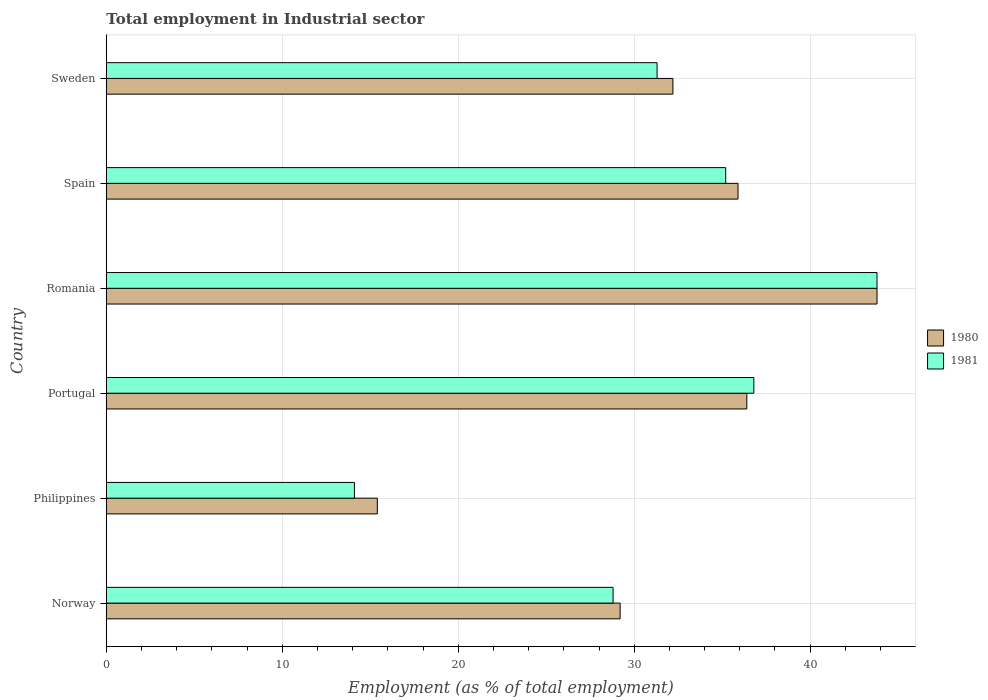How many groups of bars are there?
Offer a very short reply. 6. Are the number of bars per tick equal to the number of legend labels?
Make the answer very short. Yes. Are the number of bars on each tick of the Y-axis equal?
Your answer should be very brief. Yes. What is the label of the 2nd group of bars from the top?
Give a very brief answer. Spain. In how many cases, is the number of bars for a given country not equal to the number of legend labels?
Provide a succinct answer. 0. What is the employment in industrial sector in 1981 in Philippines?
Keep it short and to the point. 14.1. Across all countries, what is the maximum employment in industrial sector in 1980?
Your answer should be very brief. 43.8. Across all countries, what is the minimum employment in industrial sector in 1981?
Make the answer very short. 14.1. In which country was the employment in industrial sector in 1980 maximum?
Make the answer very short. Romania. In which country was the employment in industrial sector in 1980 minimum?
Make the answer very short. Philippines. What is the total employment in industrial sector in 1981 in the graph?
Your answer should be very brief. 190. What is the difference between the employment in industrial sector in 1981 in Norway and that in Spain?
Give a very brief answer. -6.4. What is the difference between the employment in industrial sector in 1980 in Philippines and the employment in industrial sector in 1981 in Norway?
Give a very brief answer. -13.4. What is the average employment in industrial sector in 1981 per country?
Keep it short and to the point. 31.67. What is the difference between the employment in industrial sector in 1981 and employment in industrial sector in 1980 in Norway?
Offer a very short reply. -0.4. What is the ratio of the employment in industrial sector in 1980 in Portugal to that in Sweden?
Your answer should be very brief. 1.13. What is the difference between the highest and the lowest employment in industrial sector in 1980?
Ensure brevity in your answer.  28.4. In how many countries, is the employment in industrial sector in 1980 greater than the average employment in industrial sector in 1980 taken over all countries?
Make the answer very short. 4. Is the sum of the employment in industrial sector in 1981 in Portugal and Sweden greater than the maximum employment in industrial sector in 1980 across all countries?
Give a very brief answer. Yes. What does the 1st bar from the top in Philippines represents?
Make the answer very short. 1981. What does the 2nd bar from the bottom in Spain represents?
Provide a succinct answer. 1981. How many bars are there?
Make the answer very short. 12. How many countries are there in the graph?
Provide a succinct answer. 6. What is the difference between two consecutive major ticks on the X-axis?
Your response must be concise. 10. What is the title of the graph?
Your answer should be compact. Total employment in Industrial sector. Does "1981" appear as one of the legend labels in the graph?
Offer a very short reply. Yes. What is the label or title of the X-axis?
Ensure brevity in your answer.  Employment (as % of total employment). What is the label or title of the Y-axis?
Ensure brevity in your answer.  Country. What is the Employment (as % of total employment) in 1980 in Norway?
Give a very brief answer. 29.2. What is the Employment (as % of total employment) in 1981 in Norway?
Offer a very short reply. 28.8. What is the Employment (as % of total employment) in 1980 in Philippines?
Your answer should be very brief. 15.4. What is the Employment (as % of total employment) in 1981 in Philippines?
Give a very brief answer. 14.1. What is the Employment (as % of total employment) in 1980 in Portugal?
Offer a terse response. 36.4. What is the Employment (as % of total employment) of 1981 in Portugal?
Give a very brief answer. 36.8. What is the Employment (as % of total employment) in 1980 in Romania?
Your answer should be compact. 43.8. What is the Employment (as % of total employment) in 1981 in Romania?
Provide a short and direct response. 43.8. What is the Employment (as % of total employment) in 1980 in Spain?
Offer a terse response. 35.9. What is the Employment (as % of total employment) in 1981 in Spain?
Offer a terse response. 35.2. What is the Employment (as % of total employment) of 1980 in Sweden?
Ensure brevity in your answer.  32.2. What is the Employment (as % of total employment) of 1981 in Sweden?
Your response must be concise. 31.3. Across all countries, what is the maximum Employment (as % of total employment) of 1980?
Provide a short and direct response. 43.8. Across all countries, what is the maximum Employment (as % of total employment) in 1981?
Your response must be concise. 43.8. Across all countries, what is the minimum Employment (as % of total employment) of 1980?
Offer a very short reply. 15.4. Across all countries, what is the minimum Employment (as % of total employment) of 1981?
Your response must be concise. 14.1. What is the total Employment (as % of total employment) of 1980 in the graph?
Make the answer very short. 192.9. What is the total Employment (as % of total employment) of 1981 in the graph?
Offer a very short reply. 190. What is the difference between the Employment (as % of total employment) in 1981 in Norway and that in Philippines?
Your answer should be very brief. 14.7. What is the difference between the Employment (as % of total employment) in 1980 in Norway and that in Portugal?
Your answer should be very brief. -7.2. What is the difference between the Employment (as % of total employment) in 1981 in Norway and that in Portugal?
Offer a very short reply. -8. What is the difference between the Employment (as % of total employment) in 1980 in Norway and that in Romania?
Provide a succinct answer. -14.6. What is the difference between the Employment (as % of total employment) of 1981 in Norway and that in Romania?
Make the answer very short. -15. What is the difference between the Employment (as % of total employment) of 1980 in Norway and that in Spain?
Provide a succinct answer. -6.7. What is the difference between the Employment (as % of total employment) of 1980 in Philippines and that in Portugal?
Your answer should be compact. -21. What is the difference between the Employment (as % of total employment) of 1981 in Philippines and that in Portugal?
Offer a very short reply. -22.7. What is the difference between the Employment (as % of total employment) in 1980 in Philippines and that in Romania?
Keep it short and to the point. -28.4. What is the difference between the Employment (as % of total employment) in 1981 in Philippines and that in Romania?
Keep it short and to the point. -29.7. What is the difference between the Employment (as % of total employment) of 1980 in Philippines and that in Spain?
Provide a short and direct response. -20.5. What is the difference between the Employment (as % of total employment) of 1981 in Philippines and that in Spain?
Give a very brief answer. -21.1. What is the difference between the Employment (as % of total employment) of 1980 in Philippines and that in Sweden?
Your answer should be compact. -16.8. What is the difference between the Employment (as % of total employment) in 1981 in Philippines and that in Sweden?
Your answer should be very brief. -17.2. What is the difference between the Employment (as % of total employment) in 1980 in Portugal and that in Spain?
Ensure brevity in your answer.  0.5. What is the difference between the Employment (as % of total employment) in 1981 in Portugal and that in Sweden?
Your response must be concise. 5.5. What is the difference between the Employment (as % of total employment) in 1981 in Romania and that in Sweden?
Offer a very short reply. 12.5. What is the difference between the Employment (as % of total employment) of 1980 in Norway and the Employment (as % of total employment) of 1981 in Portugal?
Give a very brief answer. -7.6. What is the difference between the Employment (as % of total employment) of 1980 in Norway and the Employment (as % of total employment) of 1981 in Romania?
Your answer should be very brief. -14.6. What is the difference between the Employment (as % of total employment) of 1980 in Norway and the Employment (as % of total employment) of 1981 in Sweden?
Provide a succinct answer. -2.1. What is the difference between the Employment (as % of total employment) in 1980 in Philippines and the Employment (as % of total employment) in 1981 in Portugal?
Provide a succinct answer. -21.4. What is the difference between the Employment (as % of total employment) in 1980 in Philippines and the Employment (as % of total employment) in 1981 in Romania?
Keep it short and to the point. -28.4. What is the difference between the Employment (as % of total employment) of 1980 in Philippines and the Employment (as % of total employment) of 1981 in Spain?
Your answer should be compact. -19.8. What is the difference between the Employment (as % of total employment) of 1980 in Philippines and the Employment (as % of total employment) of 1981 in Sweden?
Offer a very short reply. -15.9. What is the difference between the Employment (as % of total employment) in 1980 in Portugal and the Employment (as % of total employment) in 1981 in Spain?
Your answer should be compact. 1.2. What is the difference between the Employment (as % of total employment) of 1980 in Romania and the Employment (as % of total employment) of 1981 in Spain?
Your response must be concise. 8.6. What is the difference between the Employment (as % of total employment) of 1980 in Romania and the Employment (as % of total employment) of 1981 in Sweden?
Keep it short and to the point. 12.5. What is the difference between the Employment (as % of total employment) in 1980 in Spain and the Employment (as % of total employment) in 1981 in Sweden?
Ensure brevity in your answer.  4.6. What is the average Employment (as % of total employment) in 1980 per country?
Your answer should be very brief. 32.15. What is the average Employment (as % of total employment) in 1981 per country?
Keep it short and to the point. 31.67. What is the difference between the Employment (as % of total employment) in 1980 and Employment (as % of total employment) in 1981 in Norway?
Give a very brief answer. 0.4. What is the difference between the Employment (as % of total employment) in 1980 and Employment (as % of total employment) in 1981 in Philippines?
Provide a succinct answer. 1.3. What is the difference between the Employment (as % of total employment) of 1980 and Employment (as % of total employment) of 1981 in Sweden?
Offer a very short reply. 0.9. What is the ratio of the Employment (as % of total employment) of 1980 in Norway to that in Philippines?
Ensure brevity in your answer.  1.9. What is the ratio of the Employment (as % of total employment) of 1981 in Norway to that in Philippines?
Offer a very short reply. 2.04. What is the ratio of the Employment (as % of total employment) of 1980 in Norway to that in Portugal?
Your response must be concise. 0.8. What is the ratio of the Employment (as % of total employment) in 1981 in Norway to that in Portugal?
Your answer should be very brief. 0.78. What is the ratio of the Employment (as % of total employment) of 1980 in Norway to that in Romania?
Offer a very short reply. 0.67. What is the ratio of the Employment (as % of total employment) of 1981 in Norway to that in Romania?
Ensure brevity in your answer.  0.66. What is the ratio of the Employment (as % of total employment) of 1980 in Norway to that in Spain?
Provide a short and direct response. 0.81. What is the ratio of the Employment (as % of total employment) in 1981 in Norway to that in Spain?
Ensure brevity in your answer.  0.82. What is the ratio of the Employment (as % of total employment) in 1980 in Norway to that in Sweden?
Keep it short and to the point. 0.91. What is the ratio of the Employment (as % of total employment) of 1981 in Norway to that in Sweden?
Give a very brief answer. 0.92. What is the ratio of the Employment (as % of total employment) of 1980 in Philippines to that in Portugal?
Provide a short and direct response. 0.42. What is the ratio of the Employment (as % of total employment) in 1981 in Philippines to that in Portugal?
Offer a terse response. 0.38. What is the ratio of the Employment (as % of total employment) in 1980 in Philippines to that in Romania?
Your answer should be compact. 0.35. What is the ratio of the Employment (as % of total employment) of 1981 in Philippines to that in Romania?
Keep it short and to the point. 0.32. What is the ratio of the Employment (as % of total employment) of 1980 in Philippines to that in Spain?
Provide a succinct answer. 0.43. What is the ratio of the Employment (as % of total employment) in 1981 in Philippines to that in Spain?
Provide a short and direct response. 0.4. What is the ratio of the Employment (as % of total employment) in 1980 in Philippines to that in Sweden?
Make the answer very short. 0.48. What is the ratio of the Employment (as % of total employment) in 1981 in Philippines to that in Sweden?
Make the answer very short. 0.45. What is the ratio of the Employment (as % of total employment) in 1980 in Portugal to that in Romania?
Provide a short and direct response. 0.83. What is the ratio of the Employment (as % of total employment) of 1981 in Portugal to that in Romania?
Offer a very short reply. 0.84. What is the ratio of the Employment (as % of total employment) of 1980 in Portugal to that in Spain?
Ensure brevity in your answer.  1.01. What is the ratio of the Employment (as % of total employment) in 1981 in Portugal to that in Spain?
Keep it short and to the point. 1.05. What is the ratio of the Employment (as % of total employment) of 1980 in Portugal to that in Sweden?
Provide a short and direct response. 1.13. What is the ratio of the Employment (as % of total employment) of 1981 in Portugal to that in Sweden?
Give a very brief answer. 1.18. What is the ratio of the Employment (as % of total employment) of 1980 in Romania to that in Spain?
Provide a succinct answer. 1.22. What is the ratio of the Employment (as % of total employment) in 1981 in Romania to that in Spain?
Make the answer very short. 1.24. What is the ratio of the Employment (as % of total employment) in 1980 in Romania to that in Sweden?
Give a very brief answer. 1.36. What is the ratio of the Employment (as % of total employment) of 1981 in Romania to that in Sweden?
Keep it short and to the point. 1.4. What is the ratio of the Employment (as % of total employment) in 1980 in Spain to that in Sweden?
Give a very brief answer. 1.11. What is the ratio of the Employment (as % of total employment) of 1981 in Spain to that in Sweden?
Provide a succinct answer. 1.12. What is the difference between the highest and the lowest Employment (as % of total employment) of 1980?
Offer a terse response. 28.4. What is the difference between the highest and the lowest Employment (as % of total employment) of 1981?
Provide a short and direct response. 29.7. 